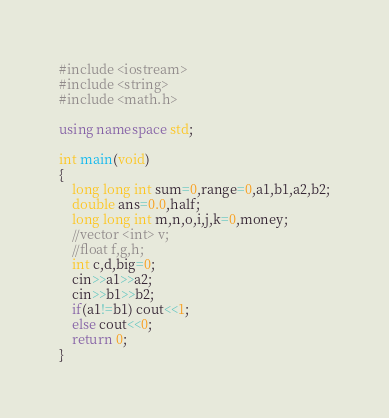<code> <loc_0><loc_0><loc_500><loc_500><_C++_>#include <iostream>
#include <string>
#include <math.h>

using namespace std;

int main(void)
{
    long long int sum=0,range=0,a1,b1,a2,b2;
    double ans=0.0,half;
    long long int m,n,o,i,j,k=0,money;
    //vector <int> v;
    //float f,g,h;
    int c,d,big=0;
    cin>>a1>>a2;
    cin>>b1>>b2;
    if(a1!=b1) cout<<1;
    else cout<<0;
    return 0;
}



</code> 